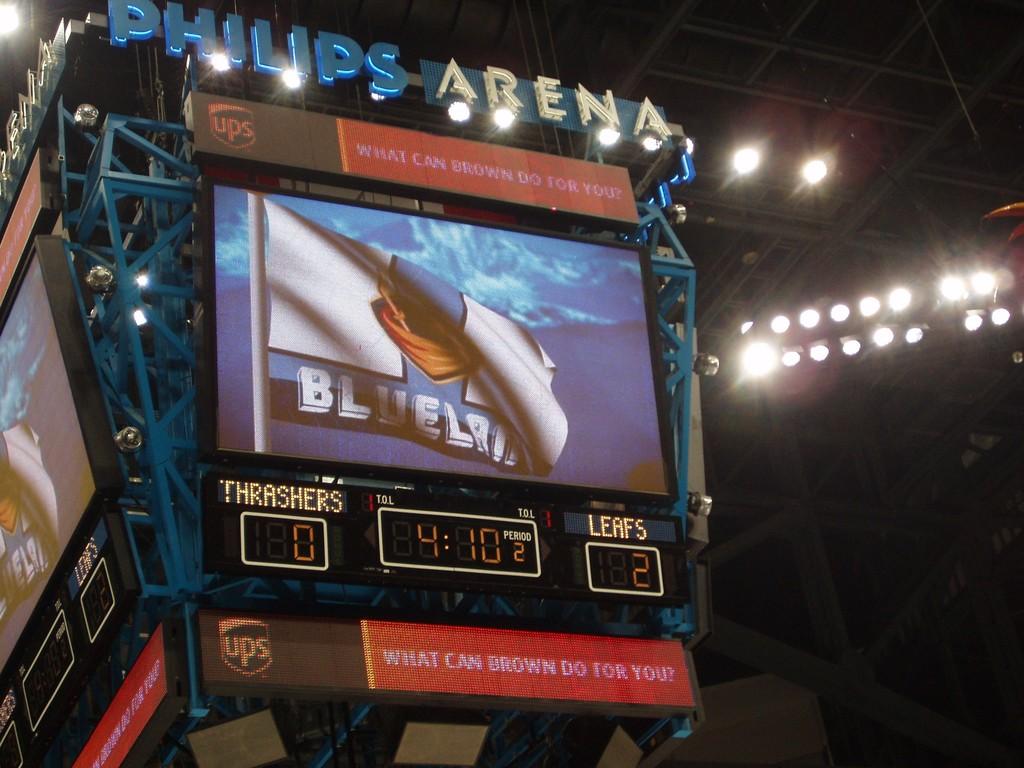Who is playing the leafs?
Ensure brevity in your answer.  Thrashers. Where is this arena located?
Your response must be concise. Unanswerable. 